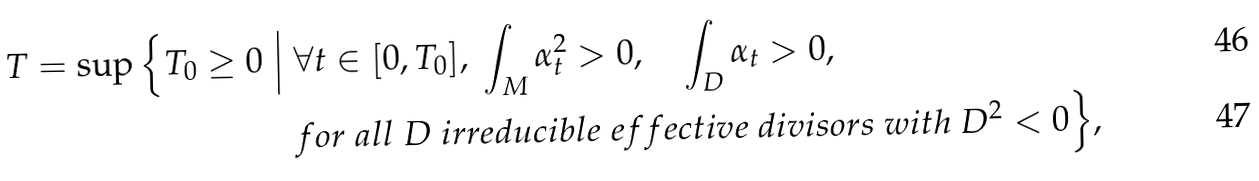Convert formula to latex. <formula><loc_0><loc_0><loc_500><loc_500>T = \sup \Big \{ T _ { 0 } \geq 0 \ \Big | \ & \forall t \in [ 0 , T _ { 0 } ] , \ \int _ { M } \alpha _ { t } ^ { 2 } > 0 , \quad \int _ { D } \alpha _ { t } > 0 , \\ & f o r \ a l l \ D \ i r r e d u c i b l e \ e f f e c t i v e \ d i v i s o r s \ w i t h \ D ^ { 2 } < 0 \Big \} ,</formula> 